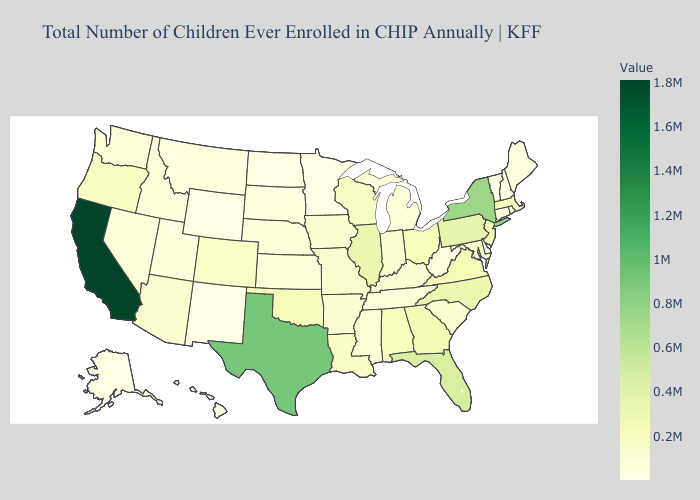Among the states that border Mississippi , does Louisiana have the highest value?
Give a very brief answer. No. Does the map have missing data?
Give a very brief answer. No. Among the states that border Delaware , does Maryland have the lowest value?
Give a very brief answer. Yes. Which states have the lowest value in the West?
Write a very short answer. Wyoming. Does Nevada have the lowest value in the West?
Concise answer only. No. Among the states that border Kentucky , which have the highest value?
Write a very short answer. Illinois. Does New Hampshire have the lowest value in the Northeast?
Concise answer only. No. Does Iowa have the lowest value in the MidWest?
Be succinct. No. 